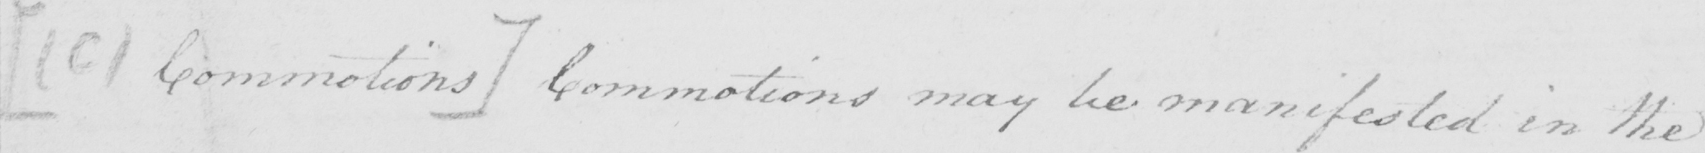Transcribe the text shown in this historical manuscript line. [  ( c )  Commotions ]  Commotions may be manifested in the 